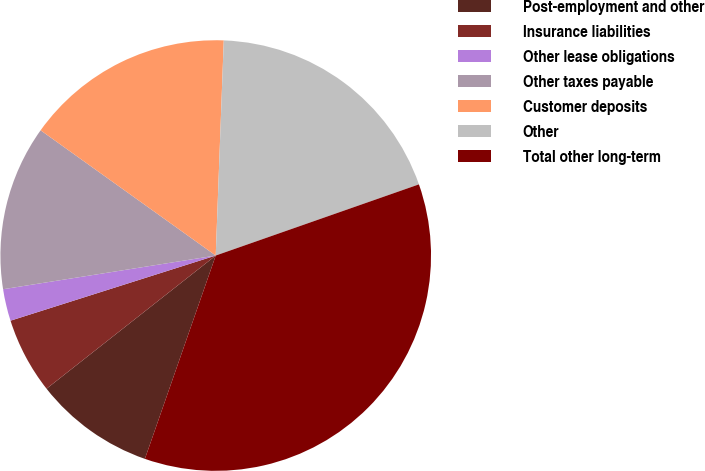Convert chart. <chart><loc_0><loc_0><loc_500><loc_500><pie_chart><fcel>Post-employment and other<fcel>Insurance liabilities<fcel>Other lease obligations<fcel>Other taxes payable<fcel>Customer deposits<fcel>Other<fcel>Total other long-term<nl><fcel>9.05%<fcel>5.72%<fcel>2.39%<fcel>12.38%<fcel>15.71%<fcel>19.04%<fcel>35.69%<nl></chart> 